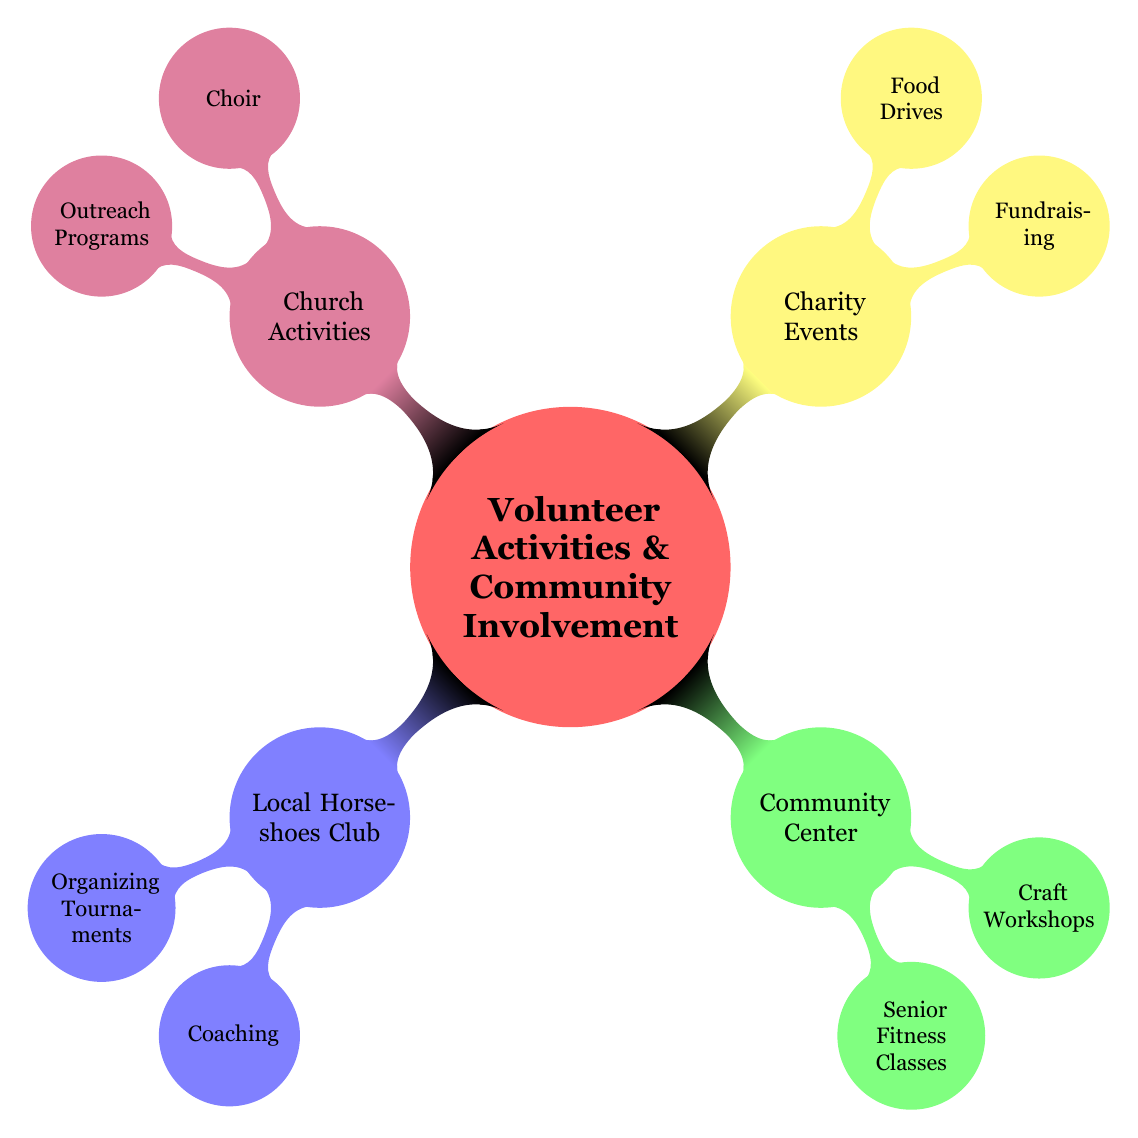What is one activity in the Local Horseshoes Club? The diagram indicates two activities under the Local Horseshoes Club: "Organizing Tournaments" and "Coaching." Therefore, any of these could be considered a valid answer, but only one is required here.
Answer: Organizing Tournaments How many activities are listed under Charity Events? There are two activities mentioned under the Charity Events node: "Fundraising" and "Food Drives." As we count these, we confirm there are two distinct activities.
Answer: 2 What color represents Community Center in the diagram? In the mind map, the Community Center is indicated with the color green. This can be found by observing the specific color coding for this node.
Answer: green Which two nodes are connected to the Choir activity? The Choir activity is found under Church Activities, which connects it to the main node "Volunteer Activities & Community Involvement" and the specific sub-node "Outreach Programs" beneath the Church Activities node. Thus, the two are: "Church Activities" and "Outreach Programs."
Answer: Church Activities, Outreach Programs Which activity involves charity fundraising? Looking at the Charity Events section, one of the activities specifically linked to charity fundraising is labeled "Fundraising." This is directly connected to the Charity Events node.
Answer: Fundraising How many total main categories are shown in the diagram? The diagram presents four main categories: Local Horseshoes Club, Community Center, Charity Events, and Church Activities. Counting these gives us the total.
Answer: 4 Which activity has a focus on seniors? Among the activities listed, "Senior Fitness Classes" directly addresses seniors. This is found under the Community Center node.
Answer: Senior Fitness Classes What are the two activities mentioned under the Charity Events category? Under the Charity Events node, we can see two activities listed, which are "Fundraising" and "Food Drives." These can be directly referenced by examining that specific section of the diagram.
Answer: Fundraising, Food Drives 